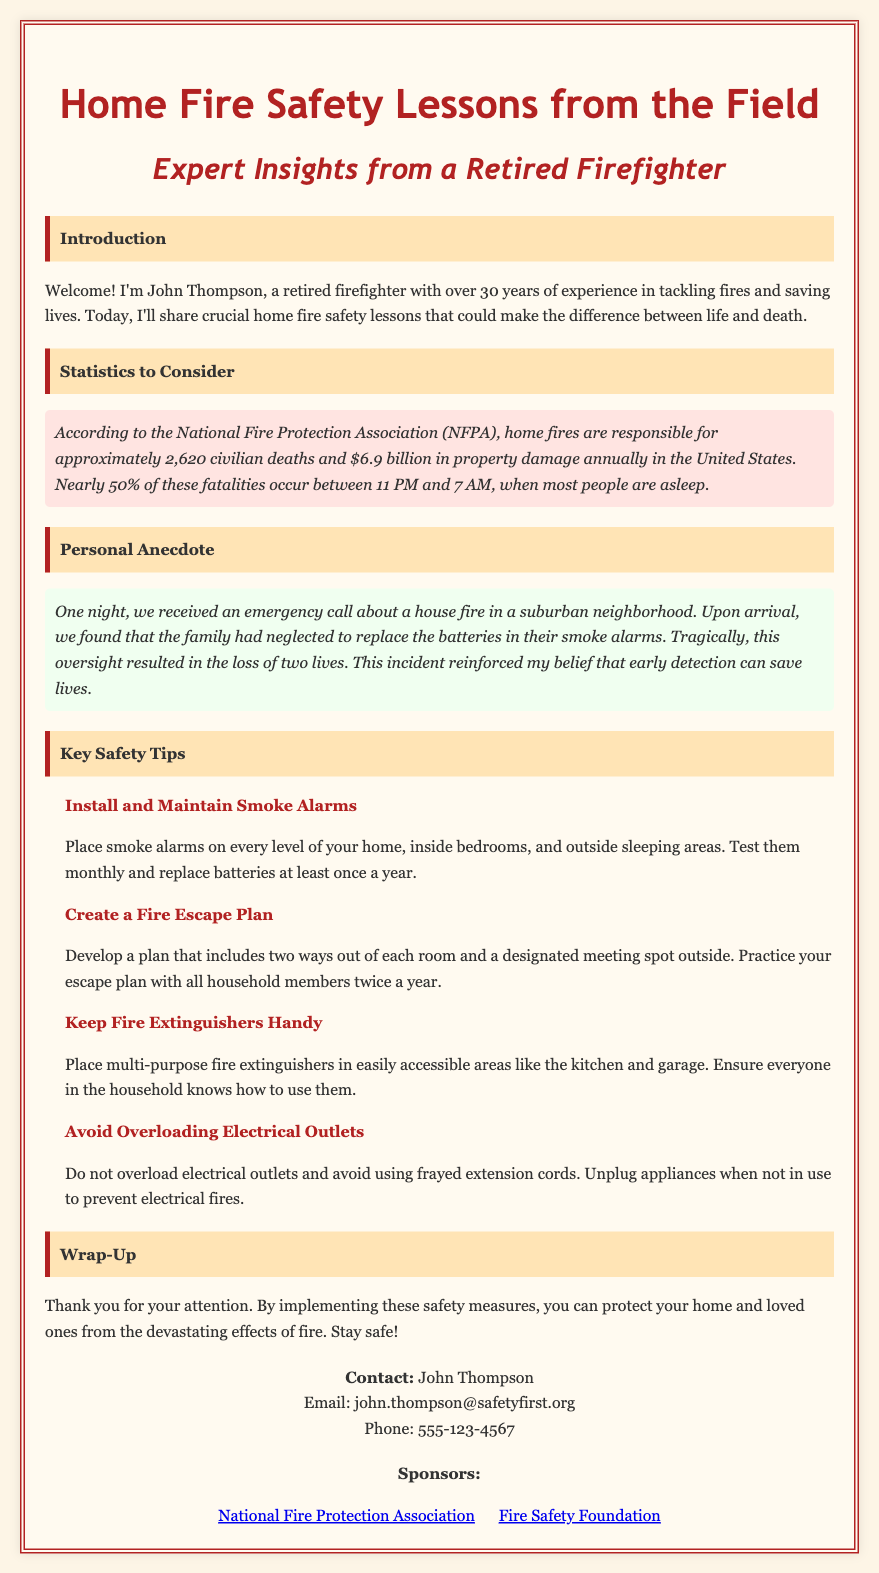What is the title of the document? The title of the document is presented prominently at the top.
Answer: Home Fire Safety Lessons from the Field Who is the author of the document? The author introduces himself at the beginning of the document.
Answer: John Thompson What does NFPA stand for? The acronym NFPA is mentioned in the statistics section of the document.
Answer: National Fire Protection Association How many civilian deaths are caused by home fires annually in the United States? The statistics section specifies the number of civilian deaths caused by home fires.
Answer: Approximately 2,620 What safety tip is related to smoke alarms? This tip is highlighted in the Key Safety Tips section, specifically regarding their installation.
Answer: Install and Maintain Smoke Alarms What incident does the personal anecdote emphasize? The anecdote illustrates a specific oversight regarding safety measures.
Answer: Neglecting to replace smoke alarm batteries How often should you practice your fire escape plan? The Key Safety Tips section specifies how often these practices should occur.
Answer: Twice a year What should you avoid doing with electrical outlets? The document provides advice on the use of electrical outlets in the Key Safety Tips section.
Answer: Overloading Who can you contact for more safety information? The contact information is provided at the end of the document.
Answer: John Thompson 